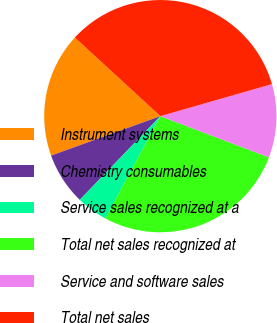Convert chart to OTSL. <chart><loc_0><loc_0><loc_500><loc_500><pie_chart><fcel>Instrument systems<fcel>Chemistry consumables<fcel>Service sales recognized at a<fcel>Total net sales recognized at<fcel>Service and software sales<fcel>Total net sales<nl><fcel>17.35%<fcel>7.29%<fcel>4.35%<fcel>27.07%<fcel>10.22%<fcel>33.72%<nl></chart> 